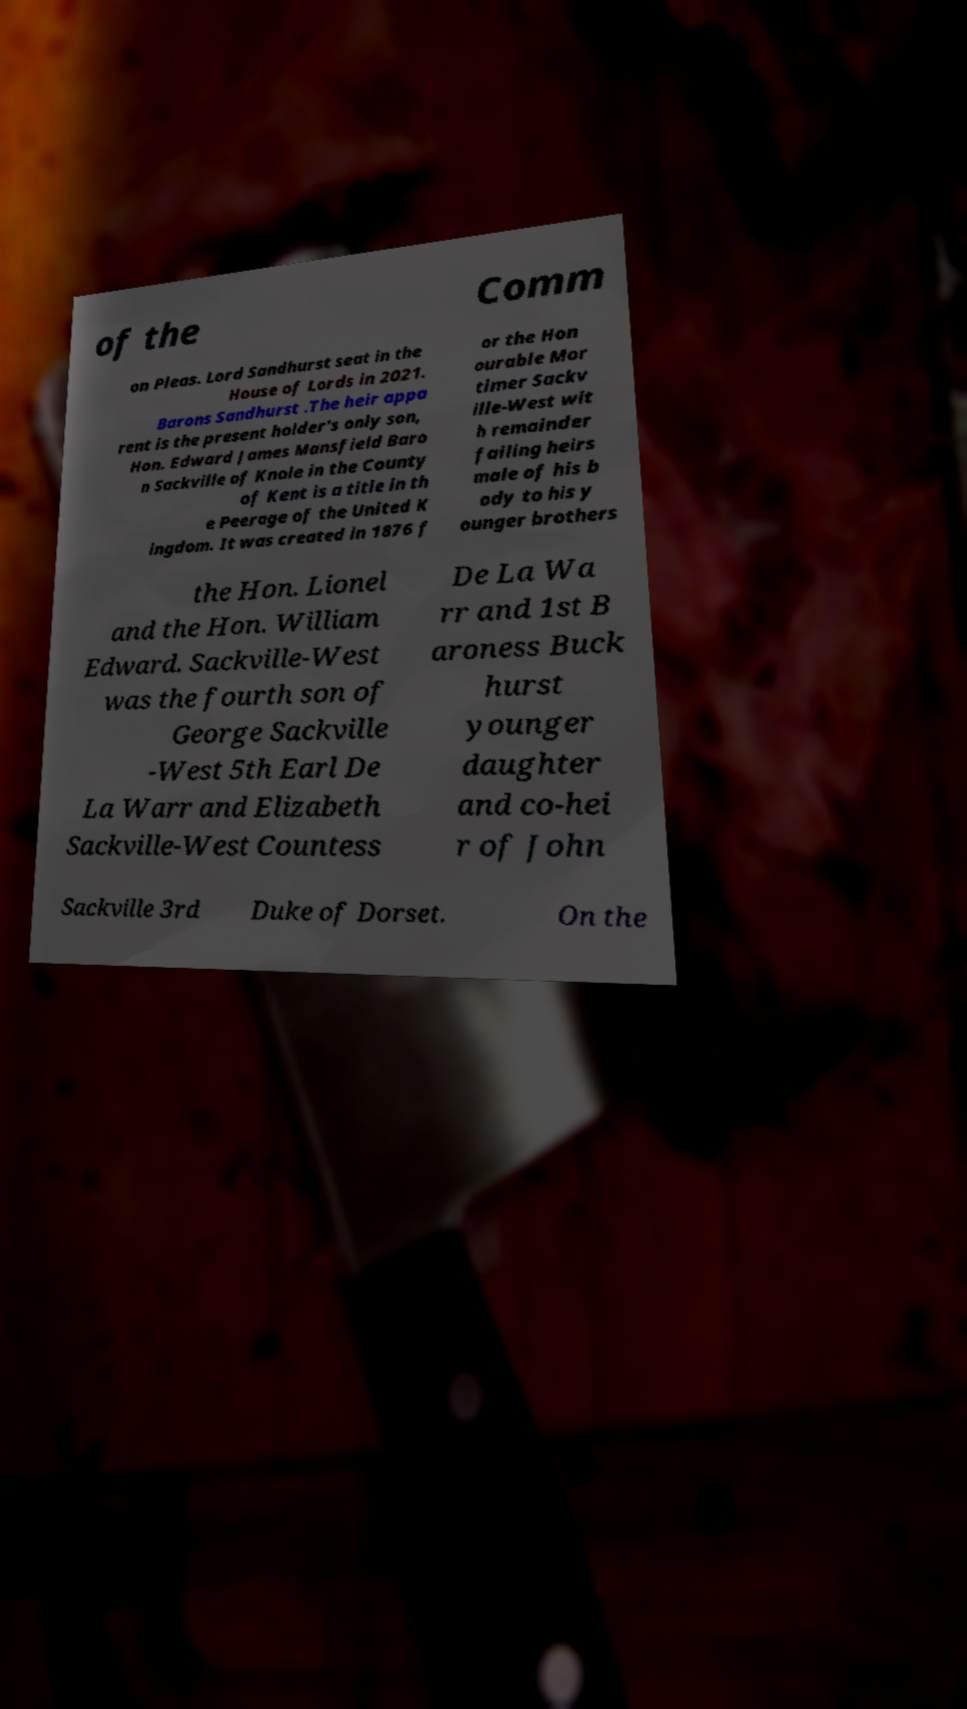Can you read and provide the text displayed in the image?This photo seems to have some interesting text. Can you extract and type it out for me? of the Comm on Pleas. Lord Sandhurst seat in the House of Lords in 2021. Barons Sandhurst .The heir appa rent is the present holder's only son, Hon. Edward James Mansfield Baro n Sackville of Knole in the County of Kent is a title in th e Peerage of the United K ingdom. It was created in 1876 f or the Hon ourable Mor timer Sackv ille-West wit h remainder failing heirs male of his b ody to his y ounger brothers the Hon. Lionel and the Hon. William Edward. Sackville-West was the fourth son of George Sackville -West 5th Earl De La Warr and Elizabeth Sackville-West Countess De La Wa rr and 1st B aroness Buck hurst younger daughter and co-hei r of John Sackville 3rd Duke of Dorset. On the 